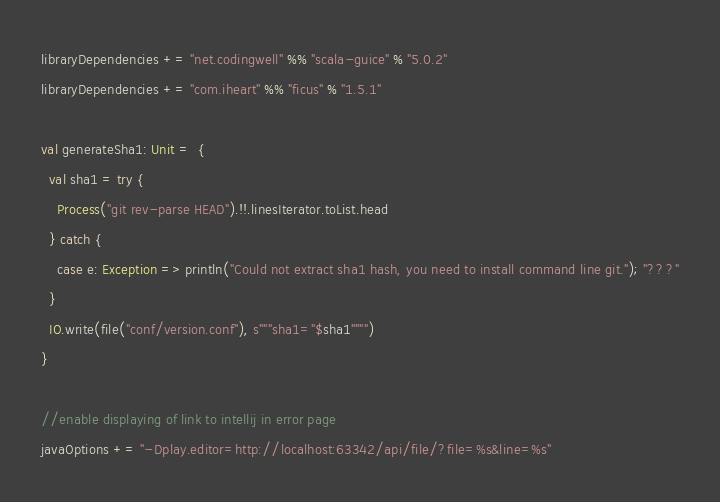<code> <loc_0><loc_0><loc_500><loc_500><_Scala_>libraryDependencies += "net.codingwell" %% "scala-guice" % "5.0.2"
libraryDependencies += "com.iheart" %% "ficus" % "1.5.1"

val generateSha1: Unit =  {
  val sha1 = try {
    Process("git rev-parse HEAD").!!.linesIterator.toList.head
  } catch {
    case e: Exception => println("Could not extract sha1 hash, you need to install command line git."); "???"
  }
  IO.write(file("conf/version.conf"), s"""sha1="$sha1"""")
}

//enable displaying of link to intellij in error page
javaOptions += "-Dplay.editor=http://localhost:63342/api/file/?file=%s&line=%s"</code> 